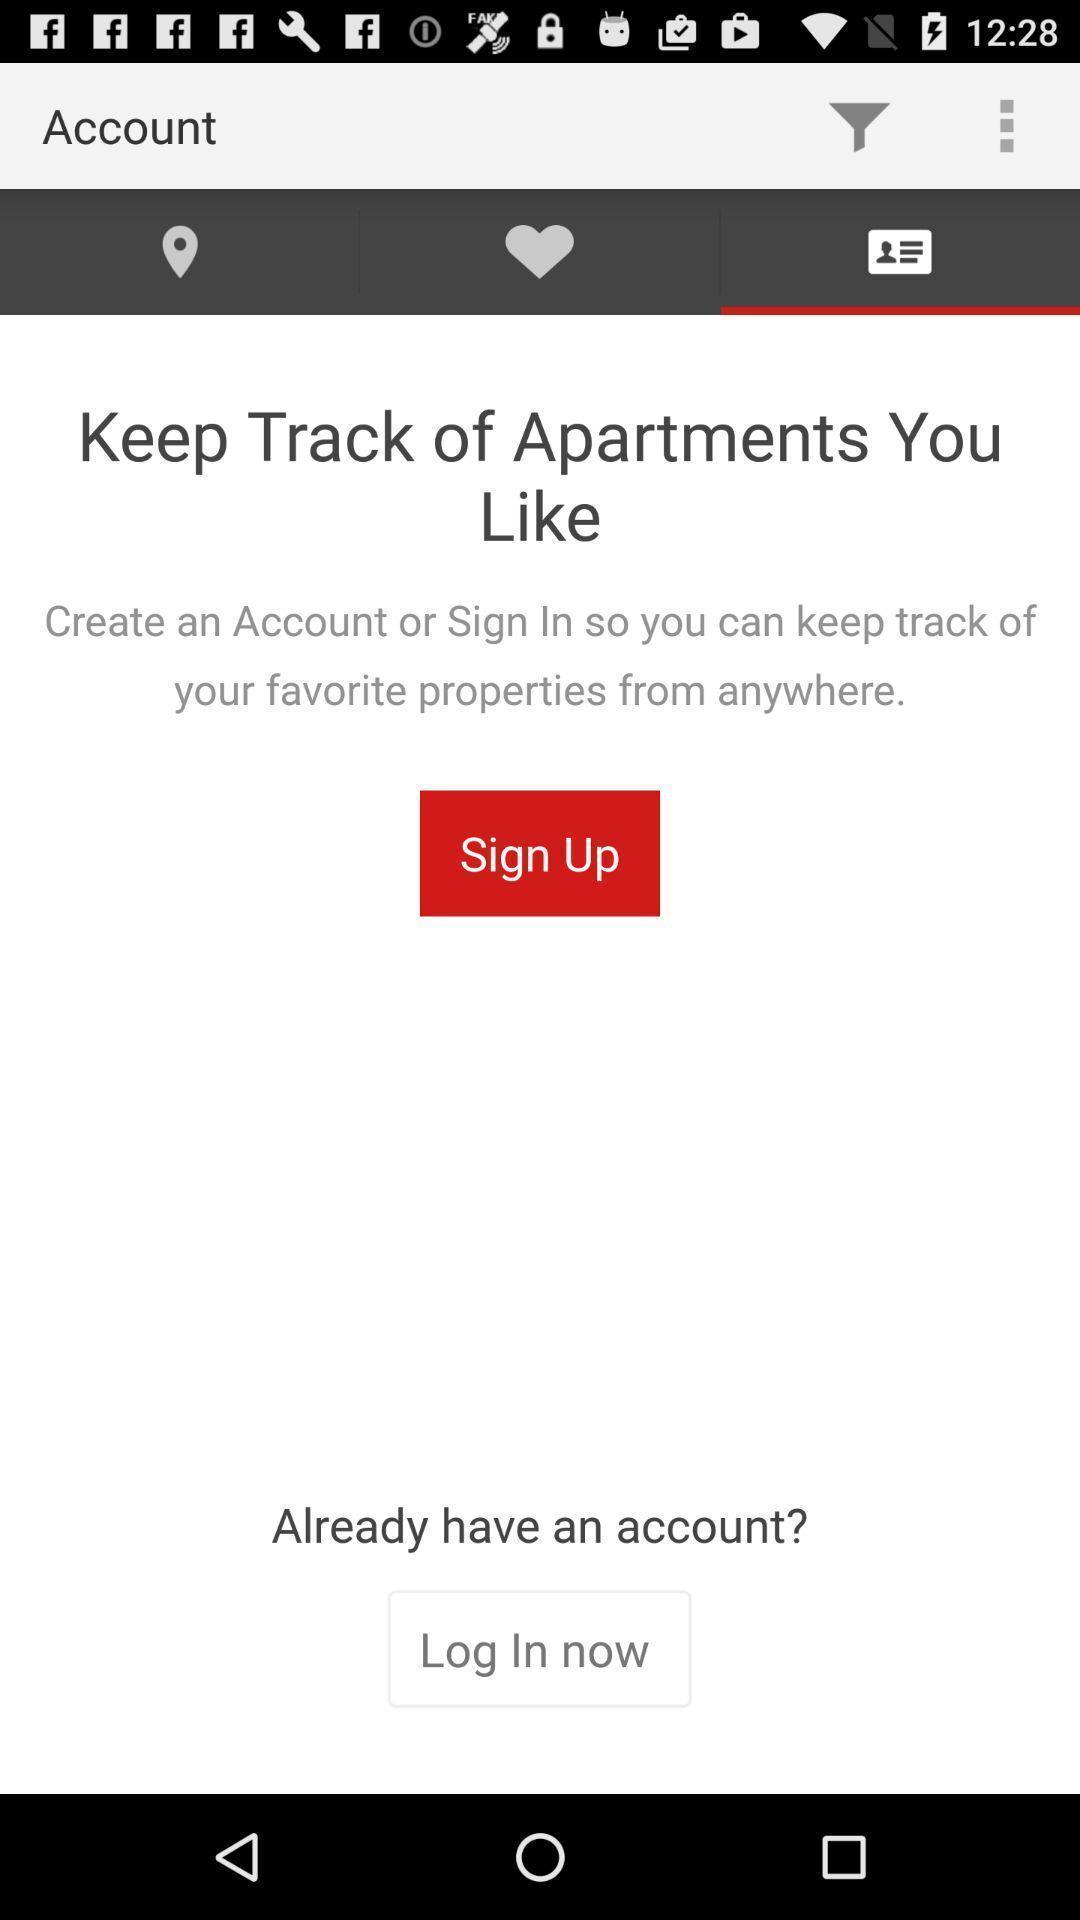What is the overall content of this screenshot? Sign up page. 